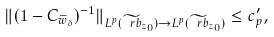Convert formula to latex. <formula><loc_0><loc_0><loc_500><loc_500>\| ( 1 - C _ { \widetilde { w } _ { \delta } } ) ^ { - 1 } \| _ { L ^ { p } ( \widetilde { \ r b } _ { z _ { 0 } } ) \to L ^ { p } ( \widetilde { \ r b } _ { z _ { 0 } } ) } \leq c ^ { \prime } _ { p } ,</formula> 